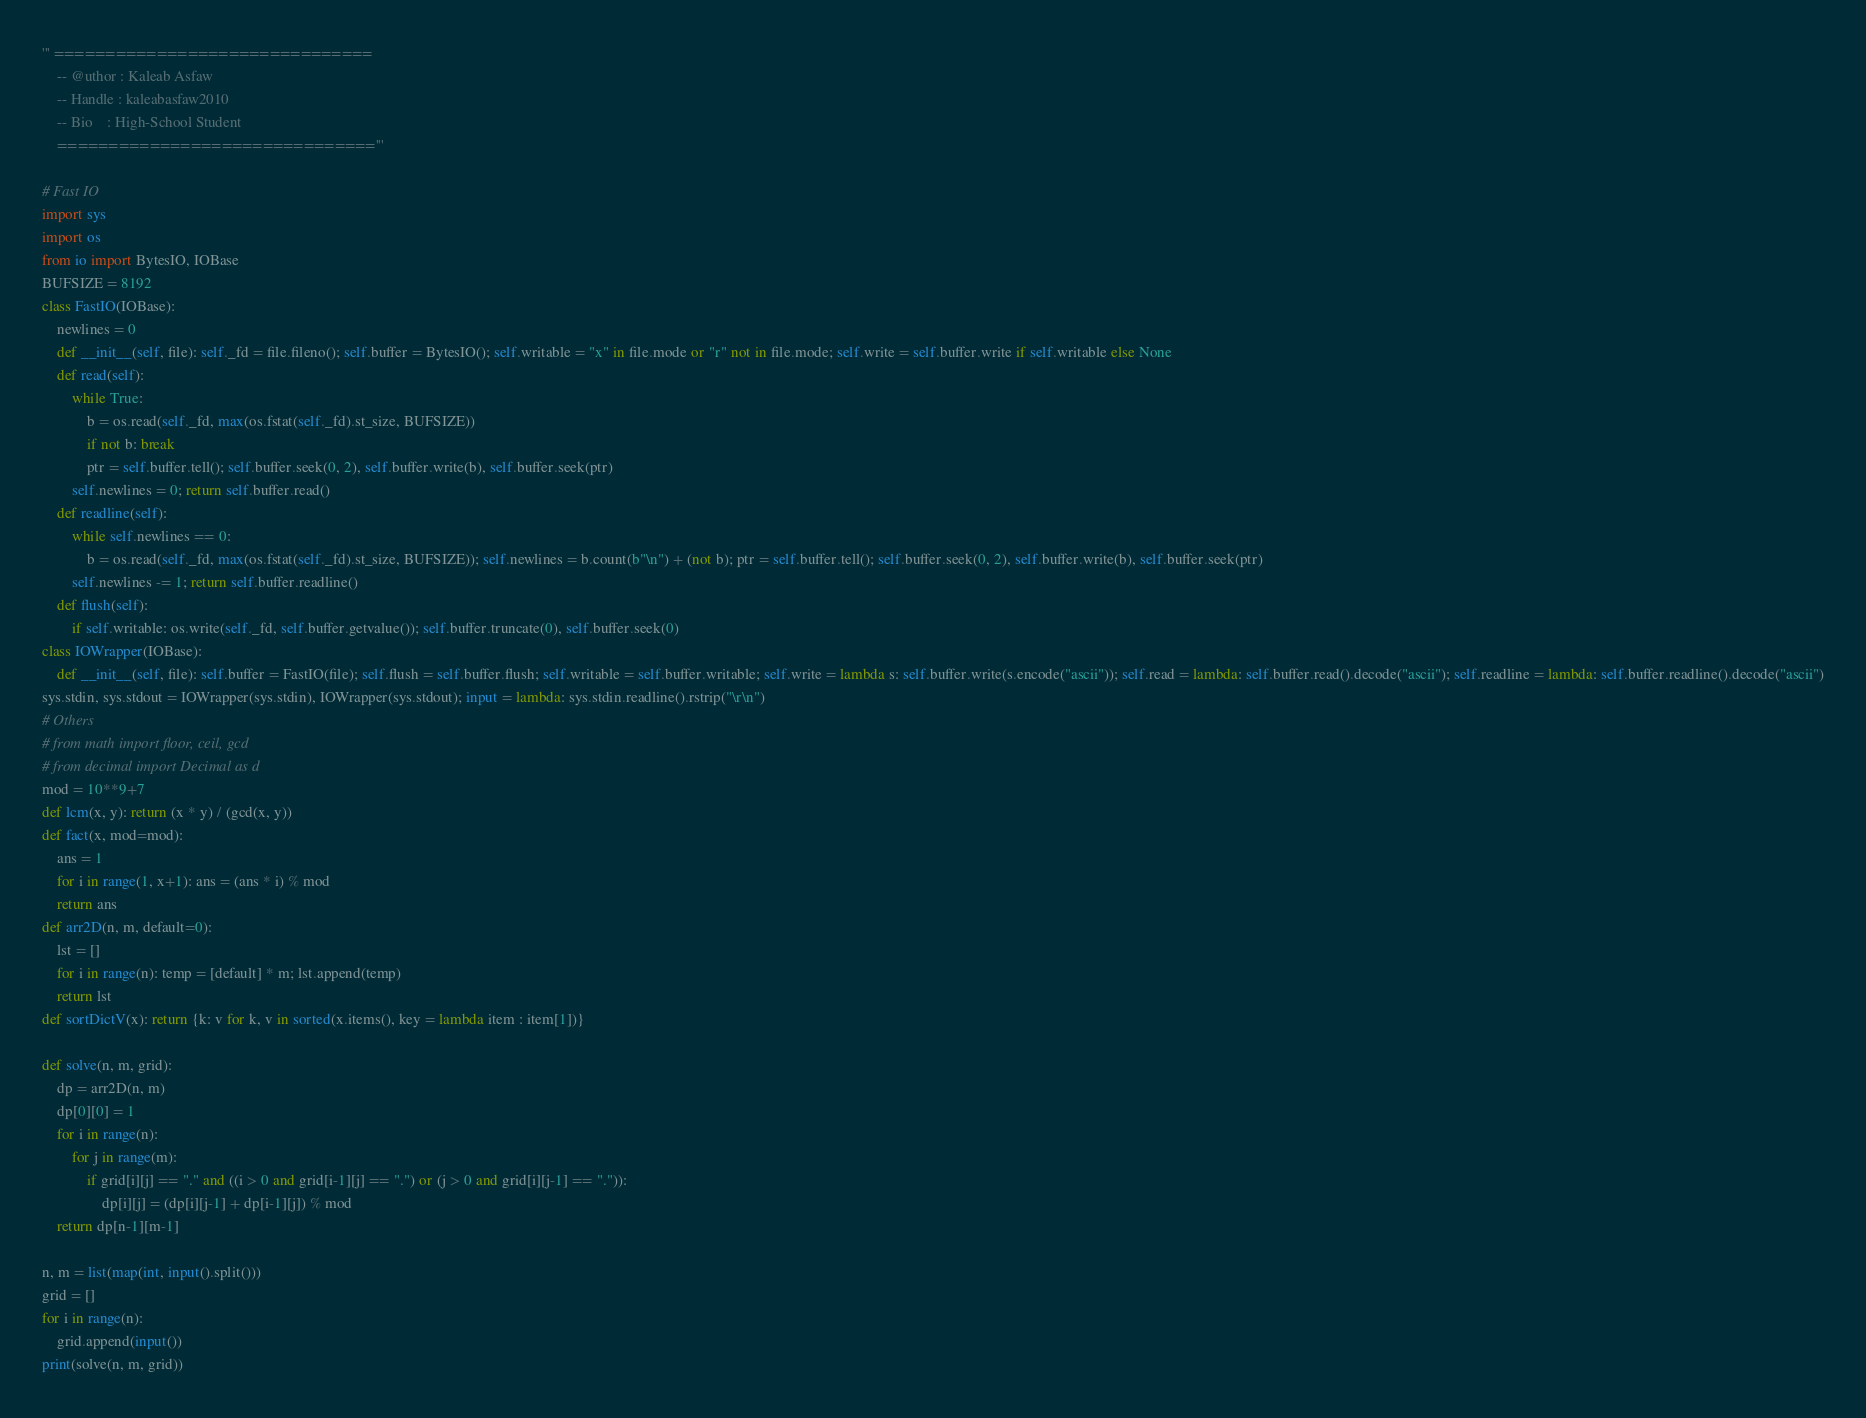Convert code to text. <code><loc_0><loc_0><loc_500><loc_500><_Python_>''' ===============================
	-- @uthor : Kaleab Asfaw
	-- Handle : kaleabasfaw2010
	-- Bio    : High-School Student
	==============================='''

# Fast IO
import sys
import os
from io import BytesIO, IOBase
BUFSIZE = 8192
class FastIO(IOBase):
	newlines = 0
	def __init__(self, file): self._fd = file.fileno(); self.buffer = BytesIO(); self.writable = "x" in file.mode or "r" not in file.mode; self.write = self.buffer.write if self.writable else None
	def read(self):
		while True:
			b = os.read(self._fd, max(os.fstat(self._fd).st_size, BUFSIZE))
			if not b: break
			ptr = self.buffer.tell(); self.buffer.seek(0, 2), self.buffer.write(b), self.buffer.seek(ptr)
		self.newlines = 0; return self.buffer.read()
	def readline(self):
		while self.newlines == 0:
			b = os.read(self._fd, max(os.fstat(self._fd).st_size, BUFSIZE)); self.newlines = b.count(b"\n") + (not b); ptr = self.buffer.tell(); self.buffer.seek(0, 2), self.buffer.write(b), self.buffer.seek(ptr)
		self.newlines -= 1; return self.buffer.readline()
	def flush(self):
		if self.writable: os.write(self._fd, self.buffer.getvalue()); self.buffer.truncate(0), self.buffer.seek(0)
class IOWrapper(IOBase):
	def __init__(self, file): self.buffer = FastIO(file); self.flush = self.buffer.flush; self.writable = self.buffer.writable; self.write = lambda s: self.buffer.write(s.encode("ascii")); self.read = lambda: self.buffer.read().decode("ascii"); self.readline = lambda: self.buffer.readline().decode("ascii")
sys.stdin, sys.stdout = IOWrapper(sys.stdin), IOWrapper(sys.stdout); input = lambda: sys.stdin.readline().rstrip("\r\n")
# Others
# from math import floor, ceil, gcd
# from decimal import Decimal as d
mod = 10**9+7
def lcm(x, y): return (x * y) / (gcd(x, y))
def fact(x, mod=mod):
	ans = 1
	for i in range(1, x+1): ans = (ans * i) % mod
	return ans
def arr2D(n, m, default=0):
	lst = []
	for i in range(n): temp = [default] * m; lst.append(temp)
	return lst
def sortDictV(x): return {k: v for k, v in sorted(x.items(), key = lambda item : item[1])}

def solve(n, m, grid):
	dp = arr2D(n, m)
	dp[0][0] = 1
	for i in range(n):
		for j in range(m):
			if grid[i][j] == "." and ((i > 0 and grid[i-1][j] == ".") or (j > 0 and grid[i][j-1] == ".")):
				dp[i][j] = (dp[i][j-1] + dp[i-1][j]) % mod
	return dp[n-1][m-1]

n, m = list(map(int, input().split()))
grid = []
for i in range(n):
	grid.append(input())
print(solve(n, m, grid))</code> 